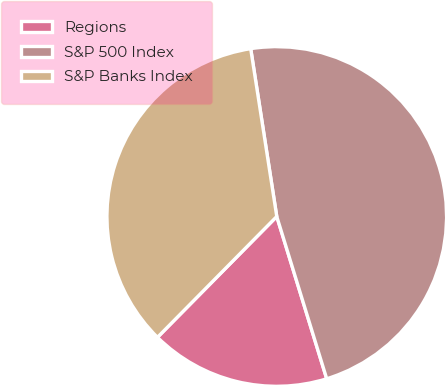Convert chart to OTSL. <chart><loc_0><loc_0><loc_500><loc_500><pie_chart><fcel>Regions<fcel>S&P 500 Index<fcel>S&P Banks Index<nl><fcel>17.15%<fcel>47.7%<fcel>35.15%<nl></chart> 